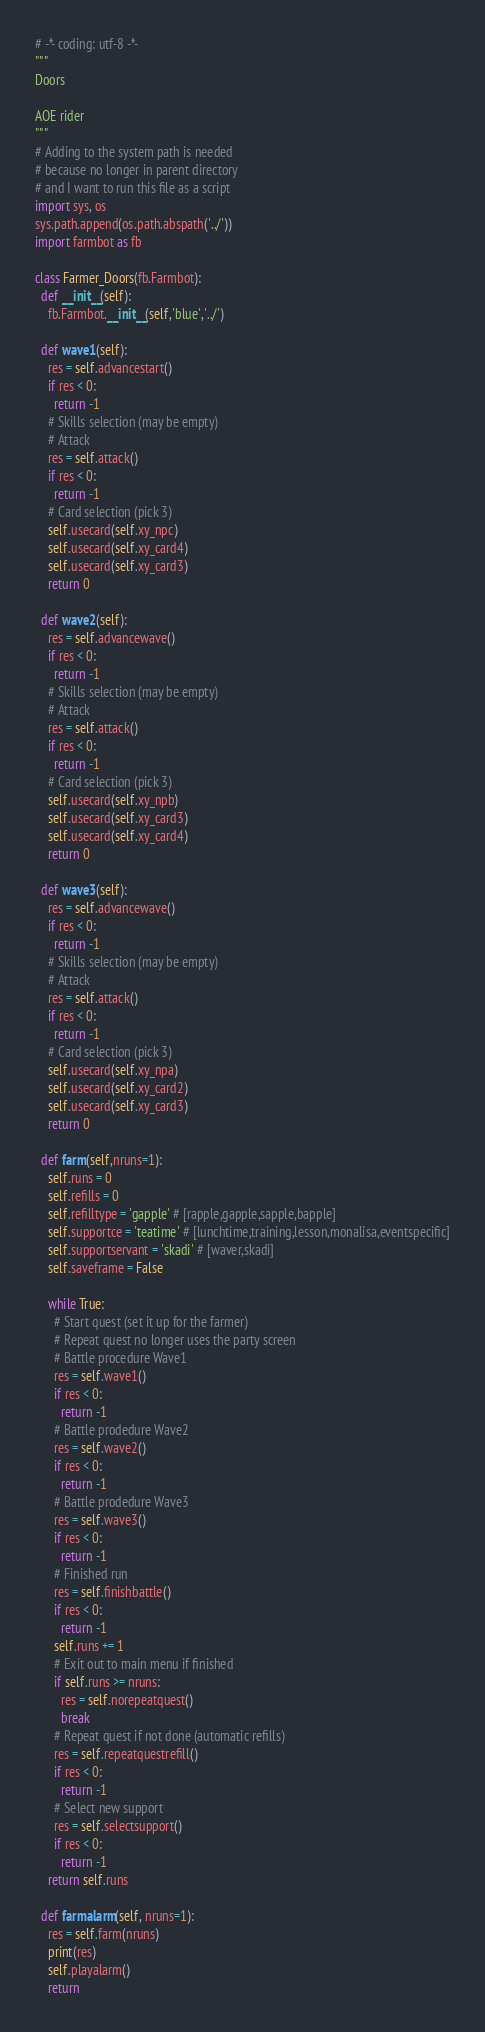Convert code to text. <code><loc_0><loc_0><loc_500><loc_500><_Python_># -*- coding: utf-8 -*-
"""
Doors

AOE rider
"""
# Adding to the system path is needed
# because no longer in parent directory
# and I want to run this file as a script
import sys, os
sys.path.append(os.path.abspath('../'))
import farmbot as fb

class Farmer_Doors(fb.Farmbot):
  def __init__(self):
    fb.Farmbot.__init__(self,'blue','../')
    
  def wave1(self):
    res = self.advancestart()
    if res < 0:
      return -1
    # Skills selection (may be empty)
    # Attack
    res = self.attack()
    if res < 0:
      return -1
    # Card selection (pick 3)
    self.usecard(self.xy_npc)
    self.usecard(self.xy_card4)
    self.usecard(self.xy_card3)
    return 0
  
  def wave2(self):
    res = self.advancewave()
    if res < 0:
      return -1
    # Skills selection (may be empty)
    # Attack
    res = self.attack()
    if res < 0:
      return -1
    # Card selection (pick 3)
    self.usecard(self.xy_npb)
    self.usecard(self.xy_card3)
    self.usecard(self.xy_card4)
    return 0
  
  def wave3(self):
    res = self.advancewave()
    if res < 0:
      return -1
    # Skills selection (may be empty)
    # Attack
    res = self.attack()
    if res < 0:
      return -1
    # Card selection (pick 3)
    self.usecard(self.xy_npa)
    self.usecard(self.xy_card2)
    self.usecard(self.xy_card3)
    return 0
    
  def farm(self,nruns=1):
    self.runs = 0
    self.refills = 0
    self.refilltype = 'gapple' # [rapple,gapple,sapple,bapple]
    self.supportce = 'teatime' # [lunchtime,training,lesson,monalisa,eventspecific]
    self.supportservant = 'skadi' # [waver,skadi]
    self.saveframe = False
    
    while True:
      # Start quest (set it up for the farmer)
      # Repeat quest no longer uses the party screen
      # Battle procedure Wave1
      res = self.wave1()
      if res < 0:
        return -1
      # Battle prodedure Wave2
      res = self.wave2()
      if res < 0:
        return -1
      # Battle prodedure Wave3
      res = self.wave3()
      if res < 0:
        return -1
      # Finished run
      res = self.finishbattle()
      if res < 0:
        return -1
      self.runs += 1
      # Exit out to main menu if finished
      if self.runs >= nruns:
        res = self.norepeatquest()
        break
      # Repeat quest if not done (automatic refills)
      res = self.repeatquestrefill()
      if res < 0:
        return -1
      # Select new support
      res = self.selectsupport()
      if res < 0:
        return -1
    return self.runs

  def farmalarm(self, nruns=1):
    res = self.farm(nruns)
    print(res)
    self.playalarm()
    return
</code> 